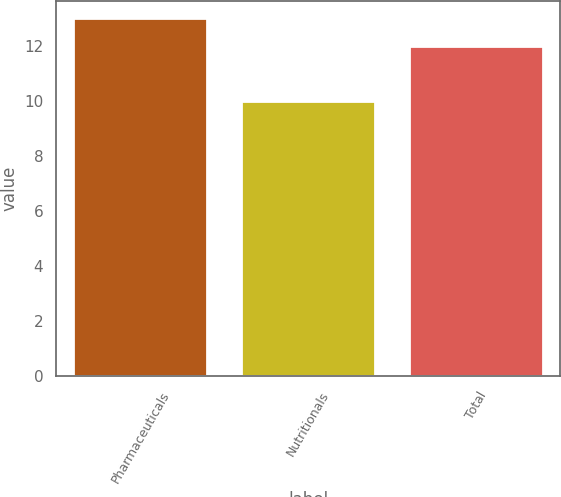Convert chart to OTSL. <chart><loc_0><loc_0><loc_500><loc_500><bar_chart><fcel>Pharmaceuticals<fcel>Nutritionals<fcel>Total<nl><fcel>13<fcel>10<fcel>12<nl></chart> 